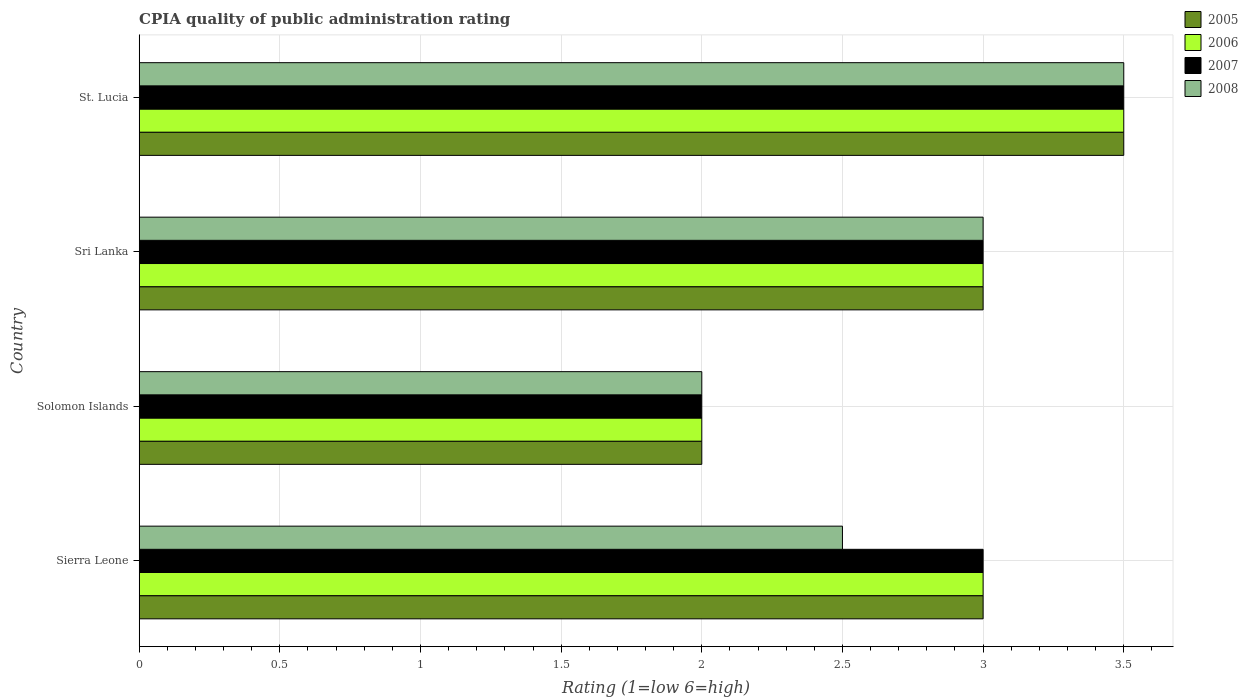How many different coloured bars are there?
Offer a very short reply. 4. Are the number of bars per tick equal to the number of legend labels?
Give a very brief answer. Yes. How many bars are there on the 1st tick from the bottom?
Your answer should be very brief. 4. What is the label of the 1st group of bars from the top?
Ensure brevity in your answer.  St. Lucia. In how many cases, is the number of bars for a given country not equal to the number of legend labels?
Provide a short and direct response. 0. What is the CPIA rating in 2008 in Solomon Islands?
Offer a terse response. 2. Across all countries, what is the minimum CPIA rating in 2005?
Provide a short and direct response. 2. In which country was the CPIA rating in 2005 maximum?
Provide a succinct answer. St. Lucia. In which country was the CPIA rating in 2006 minimum?
Give a very brief answer. Solomon Islands. What is the difference between the CPIA rating in 2005 in Sierra Leone and that in St. Lucia?
Offer a very short reply. -0.5. What is the average CPIA rating in 2006 per country?
Make the answer very short. 2.88. What is the ratio of the CPIA rating in 2008 in Sierra Leone to that in Sri Lanka?
Your answer should be very brief. 0.83. Is the CPIA rating in 2005 in Sierra Leone less than that in Solomon Islands?
Provide a short and direct response. No. Is the sum of the CPIA rating in 2008 in Solomon Islands and St. Lucia greater than the maximum CPIA rating in 2007 across all countries?
Keep it short and to the point. Yes. Is it the case that in every country, the sum of the CPIA rating in 2006 and CPIA rating in 2005 is greater than the sum of CPIA rating in 2008 and CPIA rating in 2007?
Your response must be concise. No. What does the 2nd bar from the top in Sierra Leone represents?
Your response must be concise. 2007. Is it the case that in every country, the sum of the CPIA rating in 2006 and CPIA rating in 2008 is greater than the CPIA rating in 2005?
Make the answer very short. Yes. Are the values on the major ticks of X-axis written in scientific E-notation?
Your response must be concise. No. Where does the legend appear in the graph?
Your answer should be compact. Top right. What is the title of the graph?
Ensure brevity in your answer.  CPIA quality of public administration rating. Does "2003" appear as one of the legend labels in the graph?
Make the answer very short. No. What is the label or title of the X-axis?
Offer a terse response. Rating (1=low 6=high). What is the label or title of the Y-axis?
Your answer should be very brief. Country. What is the Rating (1=low 6=high) in 2006 in Sierra Leone?
Offer a very short reply. 3. What is the Rating (1=low 6=high) of 2007 in Sierra Leone?
Provide a short and direct response. 3. What is the Rating (1=low 6=high) in 2005 in Solomon Islands?
Give a very brief answer. 2. What is the Rating (1=low 6=high) in 2006 in Solomon Islands?
Offer a terse response. 2. What is the Rating (1=low 6=high) in 2007 in Sri Lanka?
Offer a terse response. 3. What is the Rating (1=low 6=high) of 2008 in Sri Lanka?
Your answer should be very brief. 3. What is the Rating (1=low 6=high) in 2007 in St. Lucia?
Provide a short and direct response. 3.5. Across all countries, what is the maximum Rating (1=low 6=high) in 2007?
Make the answer very short. 3.5. Across all countries, what is the minimum Rating (1=low 6=high) of 2006?
Offer a very short reply. 2. Across all countries, what is the minimum Rating (1=low 6=high) in 2007?
Keep it short and to the point. 2. Across all countries, what is the minimum Rating (1=low 6=high) of 2008?
Offer a very short reply. 2. What is the total Rating (1=low 6=high) in 2006 in the graph?
Your response must be concise. 11.5. What is the total Rating (1=low 6=high) in 2007 in the graph?
Offer a terse response. 11.5. What is the difference between the Rating (1=low 6=high) in 2005 in Sierra Leone and that in Solomon Islands?
Give a very brief answer. 1. What is the difference between the Rating (1=low 6=high) in 2007 in Sierra Leone and that in Solomon Islands?
Keep it short and to the point. 1. What is the difference between the Rating (1=low 6=high) in 2008 in Sierra Leone and that in Solomon Islands?
Provide a short and direct response. 0.5. What is the difference between the Rating (1=low 6=high) of 2005 in Sierra Leone and that in Sri Lanka?
Your response must be concise. 0. What is the difference between the Rating (1=low 6=high) in 2006 in Sierra Leone and that in Sri Lanka?
Your response must be concise. 0. What is the difference between the Rating (1=low 6=high) of 2007 in Sierra Leone and that in Sri Lanka?
Your answer should be very brief. 0. What is the difference between the Rating (1=low 6=high) of 2008 in Sierra Leone and that in Sri Lanka?
Make the answer very short. -0.5. What is the difference between the Rating (1=low 6=high) in 2006 in Sierra Leone and that in St. Lucia?
Make the answer very short. -0.5. What is the difference between the Rating (1=low 6=high) in 2006 in Solomon Islands and that in Sri Lanka?
Ensure brevity in your answer.  -1. What is the difference between the Rating (1=low 6=high) in 2007 in Solomon Islands and that in Sri Lanka?
Your answer should be compact. -1. What is the difference between the Rating (1=low 6=high) of 2008 in Solomon Islands and that in St. Lucia?
Offer a very short reply. -1.5. What is the difference between the Rating (1=low 6=high) of 2006 in Sri Lanka and that in St. Lucia?
Give a very brief answer. -0.5. What is the difference between the Rating (1=low 6=high) in 2007 in Sri Lanka and that in St. Lucia?
Your response must be concise. -0.5. What is the difference between the Rating (1=low 6=high) in 2008 in Sri Lanka and that in St. Lucia?
Keep it short and to the point. -0.5. What is the difference between the Rating (1=low 6=high) in 2005 in Sierra Leone and the Rating (1=low 6=high) in 2006 in Sri Lanka?
Ensure brevity in your answer.  0. What is the difference between the Rating (1=low 6=high) in 2005 in Sierra Leone and the Rating (1=low 6=high) in 2008 in Sri Lanka?
Your answer should be compact. 0. What is the difference between the Rating (1=low 6=high) of 2005 in Sierra Leone and the Rating (1=low 6=high) of 2006 in St. Lucia?
Your answer should be very brief. -0.5. What is the difference between the Rating (1=low 6=high) of 2005 in Solomon Islands and the Rating (1=low 6=high) of 2007 in Sri Lanka?
Your response must be concise. -1. What is the difference between the Rating (1=low 6=high) in 2005 in Solomon Islands and the Rating (1=low 6=high) in 2008 in Sri Lanka?
Your answer should be very brief. -1. What is the difference between the Rating (1=low 6=high) in 2006 in Solomon Islands and the Rating (1=low 6=high) in 2007 in Sri Lanka?
Make the answer very short. -1. What is the difference between the Rating (1=low 6=high) of 2006 in Solomon Islands and the Rating (1=low 6=high) of 2008 in Sri Lanka?
Ensure brevity in your answer.  -1. What is the difference between the Rating (1=low 6=high) of 2007 in Solomon Islands and the Rating (1=low 6=high) of 2008 in Sri Lanka?
Offer a very short reply. -1. What is the difference between the Rating (1=low 6=high) in 2005 in Sri Lanka and the Rating (1=low 6=high) in 2006 in St. Lucia?
Keep it short and to the point. -0.5. What is the difference between the Rating (1=low 6=high) of 2005 in Sri Lanka and the Rating (1=low 6=high) of 2008 in St. Lucia?
Keep it short and to the point. -0.5. What is the difference between the Rating (1=low 6=high) in 2006 in Sri Lanka and the Rating (1=low 6=high) in 2008 in St. Lucia?
Give a very brief answer. -0.5. What is the difference between the Rating (1=low 6=high) of 2007 in Sri Lanka and the Rating (1=low 6=high) of 2008 in St. Lucia?
Your answer should be very brief. -0.5. What is the average Rating (1=low 6=high) in 2005 per country?
Offer a terse response. 2.88. What is the average Rating (1=low 6=high) of 2006 per country?
Your answer should be compact. 2.88. What is the average Rating (1=low 6=high) in 2007 per country?
Give a very brief answer. 2.88. What is the average Rating (1=low 6=high) of 2008 per country?
Give a very brief answer. 2.75. What is the difference between the Rating (1=low 6=high) of 2005 and Rating (1=low 6=high) of 2006 in Sierra Leone?
Ensure brevity in your answer.  0. What is the difference between the Rating (1=low 6=high) in 2007 and Rating (1=low 6=high) in 2008 in Sierra Leone?
Your answer should be very brief. 0.5. What is the difference between the Rating (1=low 6=high) in 2005 and Rating (1=low 6=high) in 2007 in Solomon Islands?
Keep it short and to the point. 0. What is the difference between the Rating (1=low 6=high) of 2006 and Rating (1=low 6=high) of 2007 in Solomon Islands?
Your answer should be compact. 0. What is the difference between the Rating (1=low 6=high) of 2006 and Rating (1=low 6=high) of 2007 in Sri Lanka?
Offer a terse response. 0. What is the difference between the Rating (1=low 6=high) of 2007 and Rating (1=low 6=high) of 2008 in Sri Lanka?
Offer a very short reply. 0. What is the difference between the Rating (1=low 6=high) in 2005 and Rating (1=low 6=high) in 2006 in St. Lucia?
Offer a terse response. 0. What is the difference between the Rating (1=low 6=high) in 2005 and Rating (1=low 6=high) in 2008 in St. Lucia?
Provide a short and direct response. 0. What is the difference between the Rating (1=low 6=high) of 2006 and Rating (1=low 6=high) of 2008 in St. Lucia?
Your answer should be very brief. 0. What is the ratio of the Rating (1=low 6=high) of 2005 in Sierra Leone to that in Solomon Islands?
Offer a very short reply. 1.5. What is the ratio of the Rating (1=low 6=high) of 2006 in Sierra Leone to that in Solomon Islands?
Provide a succinct answer. 1.5. What is the ratio of the Rating (1=low 6=high) of 2007 in Sierra Leone to that in Solomon Islands?
Your answer should be compact. 1.5. What is the ratio of the Rating (1=low 6=high) in 2005 in Sierra Leone to that in Sri Lanka?
Ensure brevity in your answer.  1. What is the ratio of the Rating (1=low 6=high) of 2007 in Sierra Leone to that in Sri Lanka?
Provide a short and direct response. 1. What is the ratio of the Rating (1=low 6=high) of 2008 in Sierra Leone to that in Sri Lanka?
Offer a very short reply. 0.83. What is the ratio of the Rating (1=low 6=high) of 2006 in Sierra Leone to that in St. Lucia?
Provide a succinct answer. 0.86. What is the ratio of the Rating (1=low 6=high) of 2007 in Sierra Leone to that in St. Lucia?
Keep it short and to the point. 0.86. What is the ratio of the Rating (1=low 6=high) in 2008 in Sierra Leone to that in St. Lucia?
Your response must be concise. 0.71. What is the ratio of the Rating (1=low 6=high) of 2005 in Solomon Islands to that in Sri Lanka?
Your answer should be compact. 0.67. What is the ratio of the Rating (1=low 6=high) of 2007 in Solomon Islands to that in Sri Lanka?
Your answer should be very brief. 0.67. What is the ratio of the Rating (1=low 6=high) of 2006 in Solomon Islands to that in St. Lucia?
Keep it short and to the point. 0.57. What is the ratio of the Rating (1=low 6=high) of 2005 in Sri Lanka to that in St. Lucia?
Provide a succinct answer. 0.86. What is the ratio of the Rating (1=low 6=high) in 2007 in Sri Lanka to that in St. Lucia?
Offer a terse response. 0.86. What is the difference between the highest and the second highest Rating (1=low 6=high) in 2005?
Keep it short and to the point. 0.5. What is the difference between the highest and the second highest Rating (1=low 6=high) of 2006?
Keep it short and to the point. 0.5. What is the difference between the highest and the lowest Rating (1=low 6=high) in 2006?
Keep it short and to the point. 1.5. What is the difference between the highest and the lowest Rating (1=low 6=high) in 2007?
Offer a very short reply. 1.5. What is the difference between the highest and the lowest Rating (1=low 6=high) of 2008?
Your answer should be very brief. 1.5. 